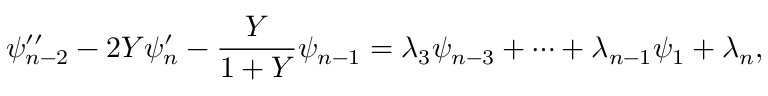Convert formula to latex. <formula><loc_0><loc_0><loc_500><loc_500>\psi _ { n - 2 } ^ { \prime \prime } - 2 Y \psi _ { n } ^ { \prime } - \frac { Y } { 1 + Y } \psi _ { n - 1 } = \lambda _ { 3 } \psi _ { n - 3 } + \cdots + \lambda _ { n - 1 } \psi _ { 1 } + \lambda _ { n } ,</formula> 